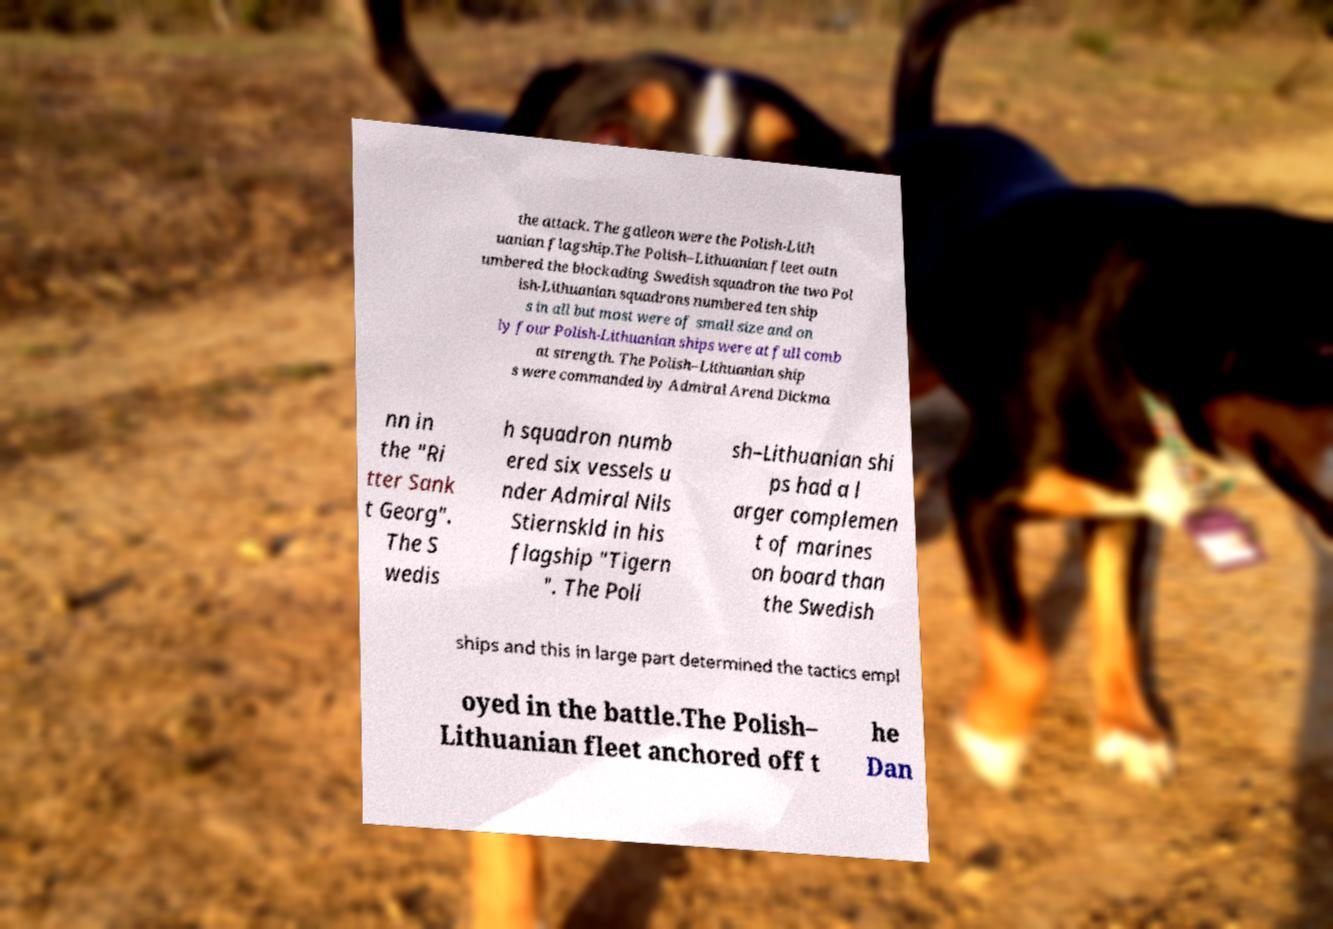What messages or text are displayed in this image? I need them in a readable, typed format. the attack. The galleon were the Polish-Lith uanian flagship.The Polish–Lithuanian fleet outn umbered the blockading Swedish squadron the two Pol ish-Lithuanian squadrons numbered ten ship s in all but most were of small size and on ly four Polish-Lithuanian ships were at full comb at strength. The Polish–Lithuanian ship s were commanded by Admiral Arend Dickma nn in the "Ri tter Sank t Georg". The S wedis h squadron numb ered six vessels u nder Admiral Nils Stiernskld in his flagship "Tigern ". The Poli sh–Lithuanian shi ps had a l arger complemen t of marines on board than the Swedish ships and this in large part determined the tactics empl oyed in the battle.The Polish– Lithuanian fleet anchored off t he Dan 